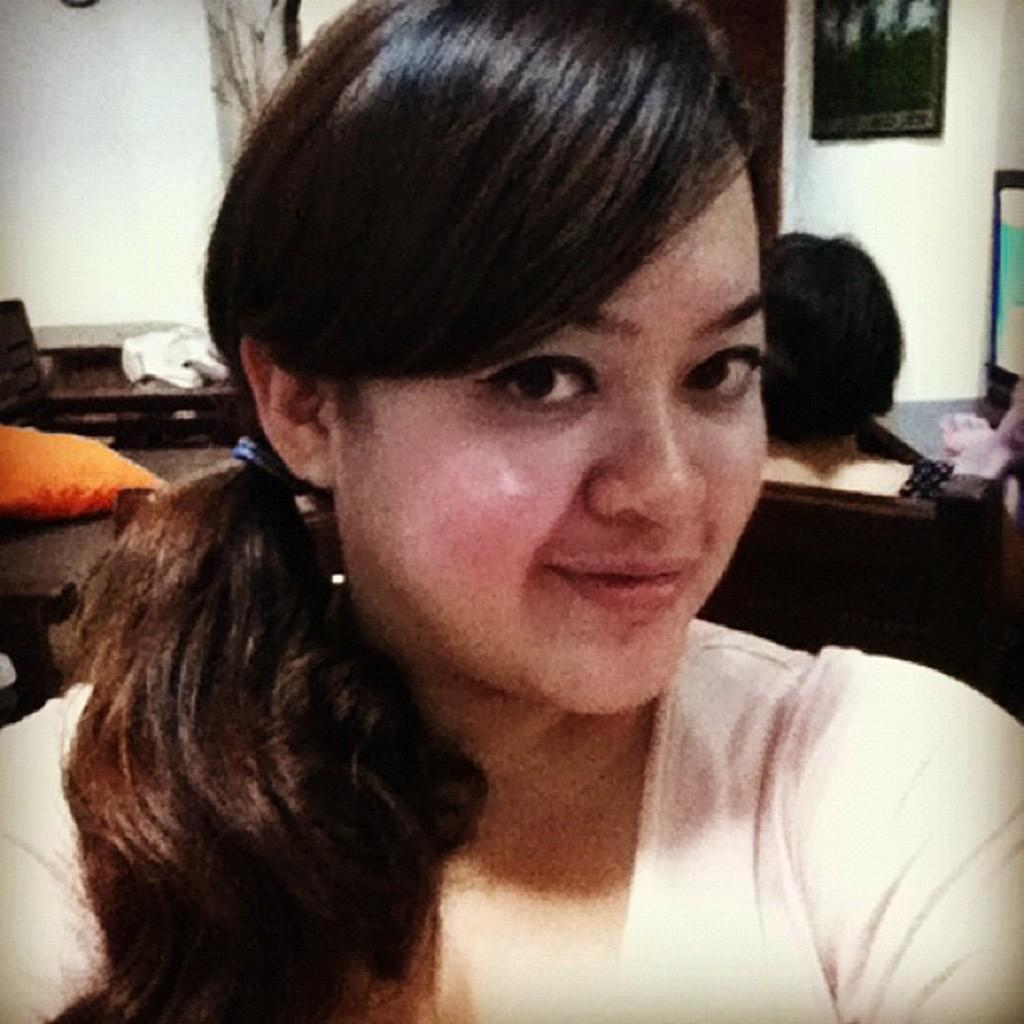Who is the main subject in the image? There is a woman in the image. Can you describe the background of the image? In the background of the image, there is a person, a pillow, a chair, a frame, a wall, and unspecified objects. What type of furniture can be seen in the background? A chair is visible in the background of the image. What is the purpose of the frame in the image? The purpose of the frame in the image is not specified, but it could be used for displaying artwork or photographs. What type of branch is the woman holding in the image? There is no branch present in the image; the woman is not holding anything. How many fingers does the person in the background have? The number of fingers the person in the background has cannot be determined from the image, as their hands are not visible. 